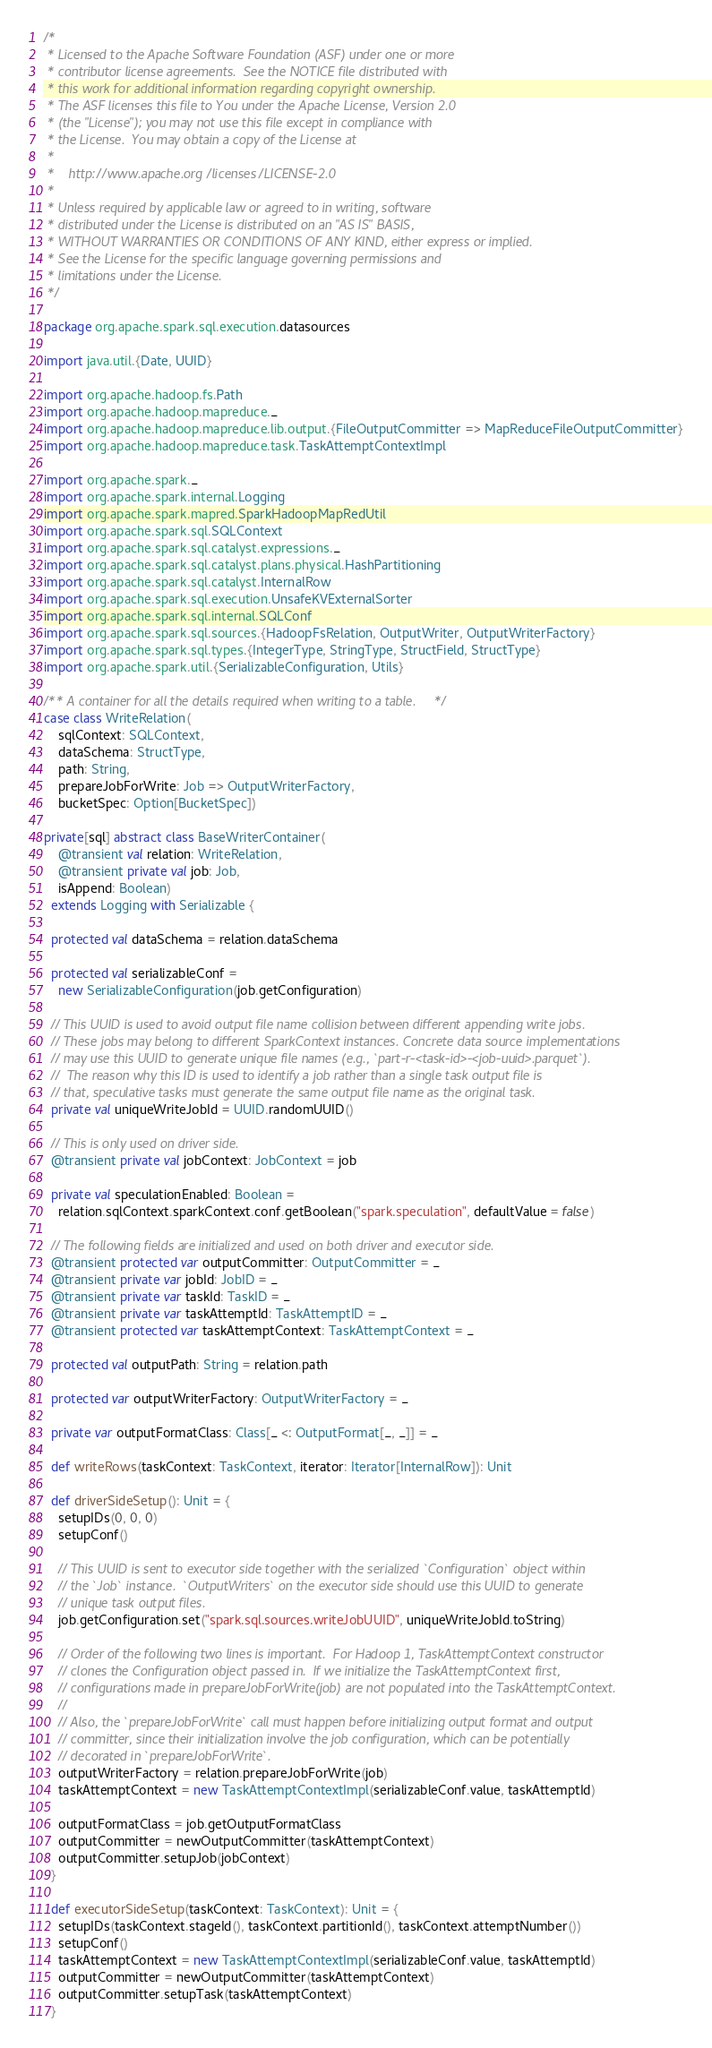Convert code to text. <code><loc_0><loc_0><loc_500><loc_500><_Scala_>/*
 * Licensed to the Apache Software Foundation (ASF) under one or more
 * contributor license agreements.  See the NOTICE file distributed with
 * this work for additional information regarding copyright ownership.
 * The ASF licenses this file to You under the Apache License, Version 2.0
 * (the "License"); you may not use this file except in compliance with
 * the License.  You may obtain a copy of the License at
 *
 *    http://www.apache.org/licenses/LICENSE-2.0
 *
 * Unless required by applicable law or agreed to in writing, software
 * distributed under the License is distributed on an "AS IS" BASIS,
 * WITHOUT WARRANTIES OR CONDITIONS OF ANY KIND, either express or implied.
 * See the License for the specific language governing permissions and
 * limitations under the License.
 */

package org.apache.spark.sql.execution.datasources

import java.util.{Date, UUID}

import org.apache.hadoop.fs.Path
import org.apache.hadoop.mapreduce._
import org.apache.hadoop.mapreduce.lib.output.{FileOutputCommitter => MapReduceFileOutputCommitter}
import org.apache.hadoop.mapreduce.task.TaskAttemptContextImpl

import org.apache.spark._
import org.apache.spark.internal.Logging
import org.apache.spark.mapred.SparkHadoopMapRedUtil
import org.apache.spark.sql.SQLContext
import org.apache.spark.sql.catalyst.expressions._
import org.apache.spark.sql.catalyst.plans.physical.HashPartitioning
import org.apache.spark.sql.catalyst.InternalRow
import org.apache.spark.sql.execution.UnsafeKVExternalSorter
import org.apache.spark.sql.internal.SQLConf
import org.apache.spark.sql.sources.{HadoopFsRelation, OutputWriter, OutputWriterFactory}
import org.apache.spark.sql.types.{IntegerType, StringType, StructField, StructType}
import org.apache.spark.util.{SerializableConfiguration, Utils}

/** A container for all the details required when writing to a table. */
case class WriteRelation(
    sqlContext: SQLContext,
    dataSchema: StructType,
    path: String,
    prepareJobForWrite: Job => OutputWriterFactory,
    bucketSpec: Option[BucketSpec])

private[sql] abstract class BaseWriterContainer(
    @transient val relation: WriteRelation,
    @transient private val job: Job,
    isAppend: Boolean)
  extends Logging with Serializable {

  protected val dataSchema = relation.dataSchema

  protected val serializableConf =
    new SerializableConfiguration(job.getConfiguration)

  // This UUID is used to avoid output file name collision between different appending write jobs.
  // These jobs may belong to different SparkContext instances. Concrete data source implementations
  // may use this UUID to generate unique file names (e.g., `part-r-<task-id>-<job-uuid>.parquet`).
  //  The reason why this ID is used to identify a job rather than a single task output file is
  // that, speculative tasks must generate the same output file name as the original task.
  private val uniqueWriteJobId = UUID.randomUUID()

  // This is only used on driver side.
  @transient private val jobContext: JobContext = job

  private val speculationEnabled: Boolean =
    relation.sqlContext.sparkContext.conf.getBoolean("spark.speculation", defaultValue = false)

  // The following fields are initialized and used on both driver and executor side.
  @transient protected var outputCommitter: OutputCommitter = _
  @transient private var jobId: JobID = _
  @transient private var taskId: TaskID = _
  @transient private var taskAttemptId: TaskAttemptID = _
  @transient protected var taskAttemptContext: TaskAttemptContext = _

  protected val outputPath: String = relation.path

  protected var outputWriterFactory: OutputWriterFactory = _

  private var outputFormatClass: Class[_ <: OutputFormat[_, _]] = _

  def writeRows(taskContext: TaskContext, iterator: Iterator[InternalRow]): Unit

  def driverSideSetup(): Unit = {
    setupIDs(0, 0, 0)
    setupConf()

    // This UUID is sent to executor side together with the serialized `Configuration` object within
    // the `Job` instance.  `OutputWriters` on the executor side should use this UUID to generate
    // unique task output files.
    job.getConfiguration.set("spark.sql.sources.writeJobUUID", uniqueWriteJobId.toString)

    // Order of the following two lines is important.  For Hadoop 1, TaskAttemptContext constructor
    // clones the Configuration object passed in.  If we initialize the TaskAttemptContext first,
    // configurations made in prepareJobForWrite(job) are not populated into the TaskAttemptContext.
    //
    // Also, the `prepareJobForWrite` call must happen before initializing output format and output
    // committer, since their initialization involve the job configuration, which can be potentially
    // decorated in `prepareJobForWrite`.
    outputWriterFactory = relation.prepareJobForWrite(job)
    taskAttemptContext = new TaskAttemptContextImpl(serializableConf.value, taskAttemptId)

    outputFormatClass = job.getOutputFormatClass
    outputCommitter = newOutputCommitter(taskAttemptContext)
    outputCommitter.setupJob(jobContext)
  }

  def executorSideSetup(taskContext: TaskContext): Unit = {
    setupIDs(taskContext.stageId(), taskContext.partitionId(), taskContext.attemptNumber())
    setupConf()
    taskAttemptContext = new TaskAttemptContextImpl(serializableConf.value, taskAttemptId)
    outputCommitter = newOutputCommitter(taskAttemptContext)
    outputCommitter.setupTask(taskAttemptContext)
  }
</code> 